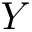<formula> <loc_0><loc_0><loc_500><loc_500>Y</formula> 